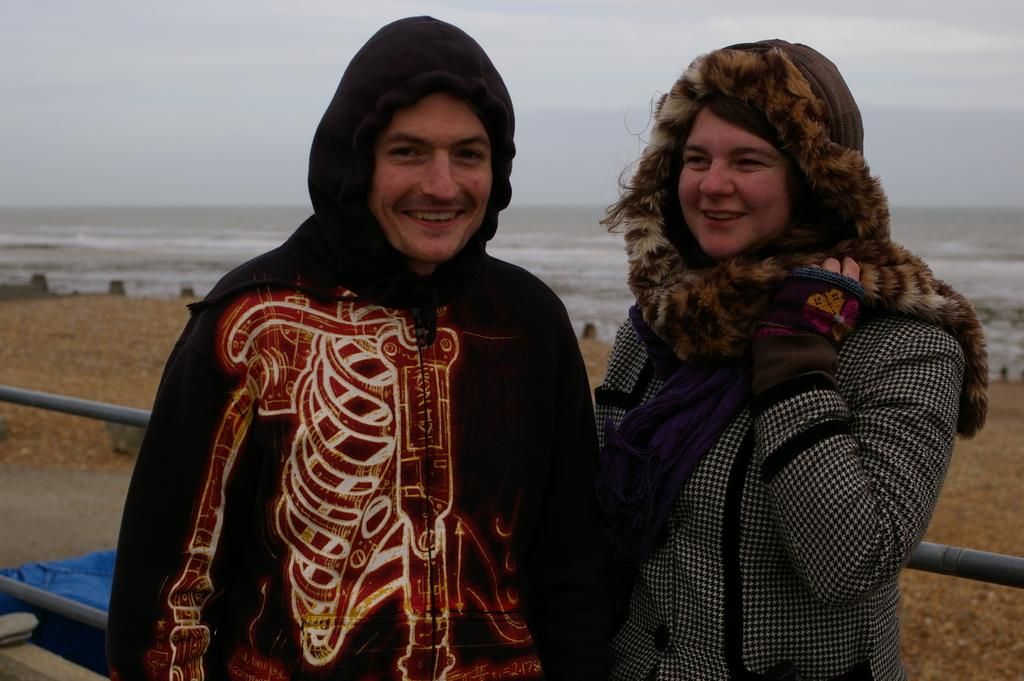Who are the people in the image? There is a man and a woman in the image. What are the man and the woman doing? Both the man and the woman are standing. How are they feeling or expressing themselves? The man and the woman are smiling. What can be seen in the background of the image? There is a fence in the background of the image, and the sea is visible as well. What is the weather like in the image? The sky is full of clouds. What type of drug can be seen in the image? There is no drug present in the image. What kind of shoe is the woman wearing in the image? The image does not show the woman's shoes, so it is not possible to determine what type of shoe she might be wearing. 